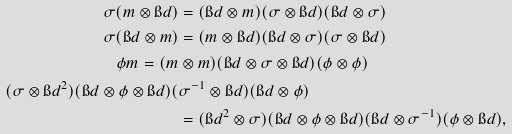Convert formula to latex. <formula><loc_0><loc_0><loc_500><loc_500>\sigma ( m \otimes \i d ) & = ( \i d \otimes m ) ( \sigma \otimes \i d ) ( \i d \otimes \sigma ) \\ \sigma ( \i d \otimes m ) & = ( m \otimes \i d ) ( \i d \otimes \sigma ) ( \sigma \otimes \i d ) \\ \phi m = ( m & \otimes m ) ( \i d \otimes \sigma \otimes \i d ) ( \phi \otimes \phi ) \\ ( \sigma \otimes \i d ^ { 2 } ) ( \i d \otimes \phi \otimes \i d ) ( & \sigma ^ { - 1 } \otimes \i d ) ( \i d \otimes \phi ) \\ & = ( \i d ^ { 2 } \otimes \sigma ) ( \i d \otimes \phi \otimes \i d ) ( \i d \otimes \sigma ^ { - 1 } ) ( \phi \otimes \i d ) ,</formula> 